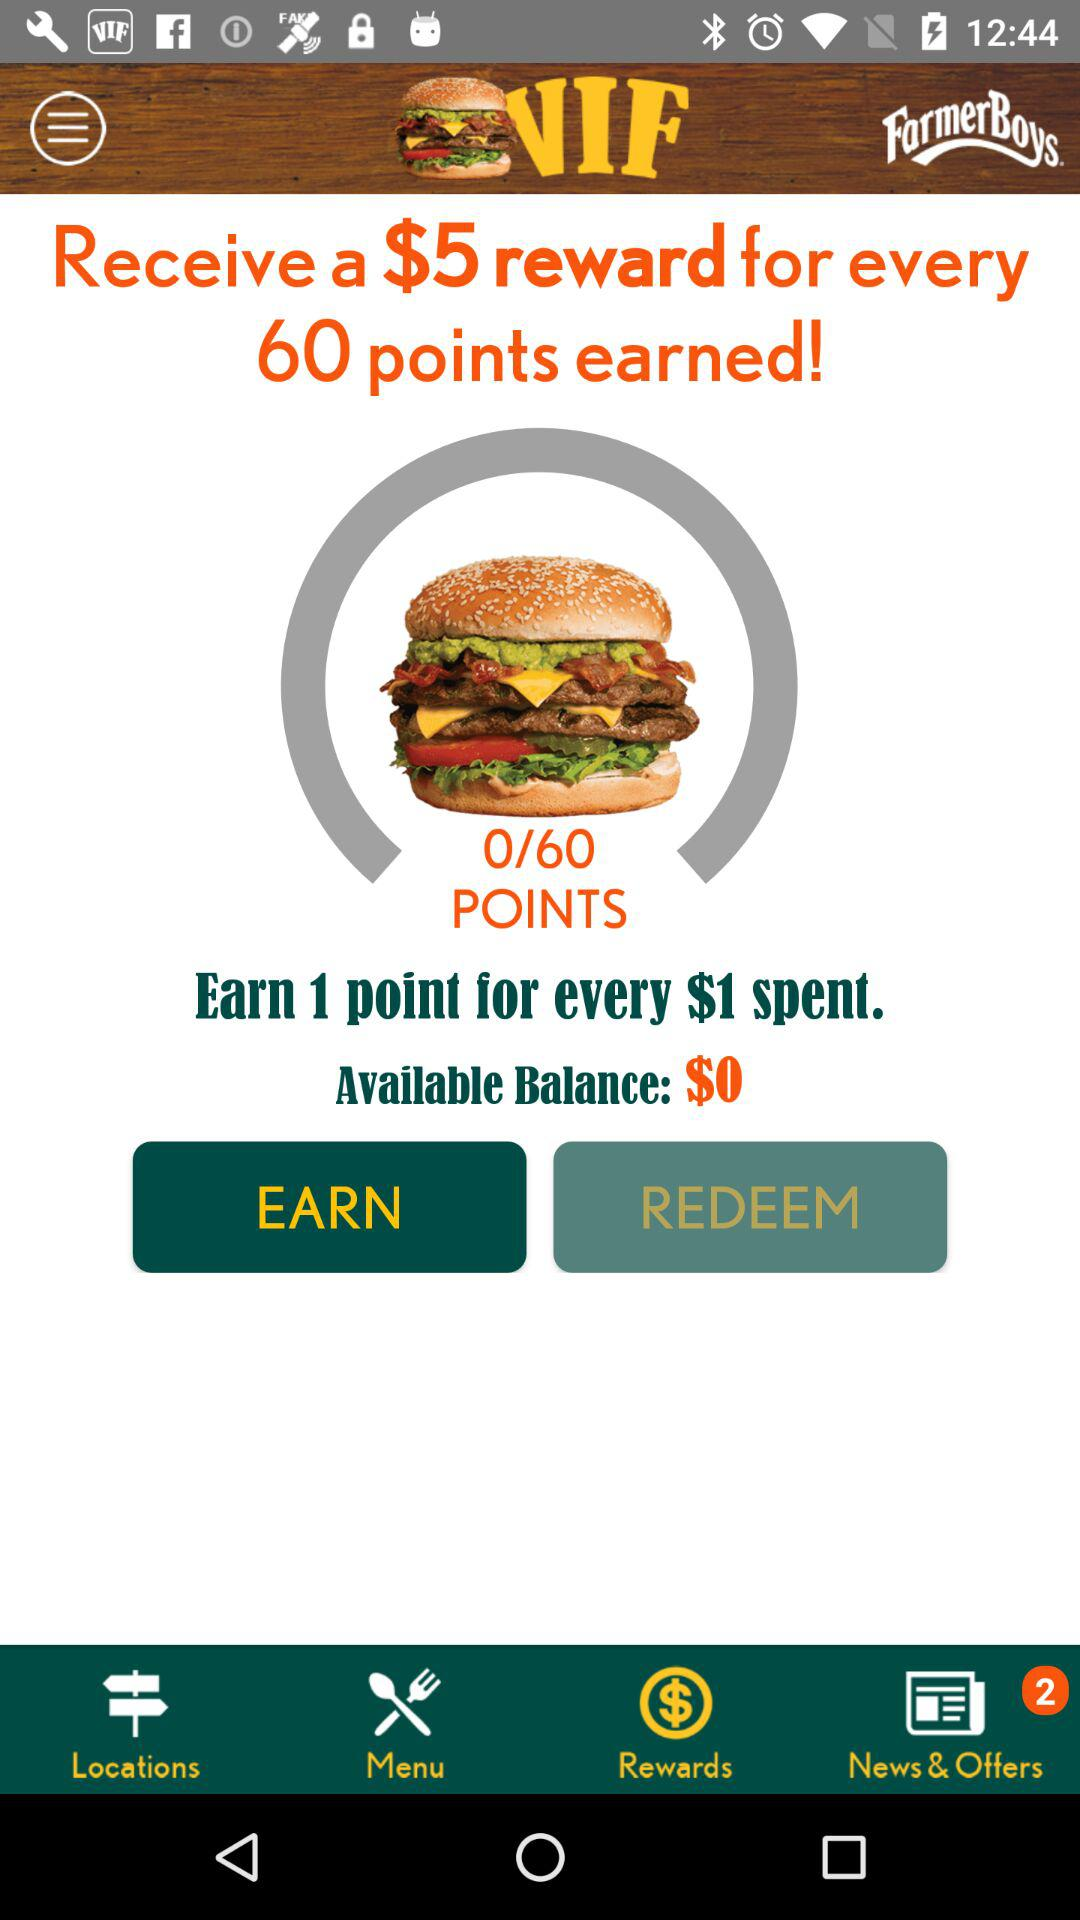How many points are required to redeem a $5 reward?
Answer the question using a single word or phrase. 60 